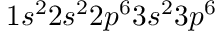<formula> <loc_0><loc_0><loc_500><loc_500>1 s ^ { 2 } 2 s ^ { 2 } 2 p ^ { 6 } 3 s ^ { 2 } 3 p ^ { 6 }</formula> 